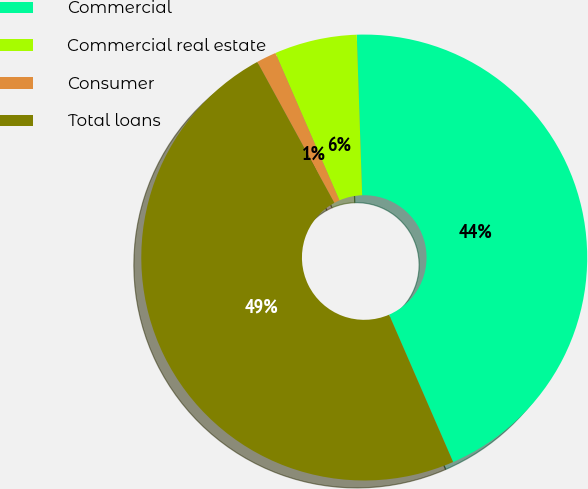<chart> <loc_0><loc_0><loc_500><loc_500><pie_chart><fcel>Commercial<fcel>Commercial real estate<fcel>Consumer<fcel>Total loans<nl><fcel>44.01%<fcel>5.99%<fcel>1.44%<fcel>48.56%<nl></chart> 